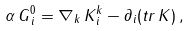<formula> <loc_0><loc_0><loc_500><loc_500>\alpha \, G ^ { 0 } _ { \, i } = \nabla _ { k } \, K ^ { k } _ { \, i } - \partial _ { i } ( t r \, K ) \, ,</formula> 